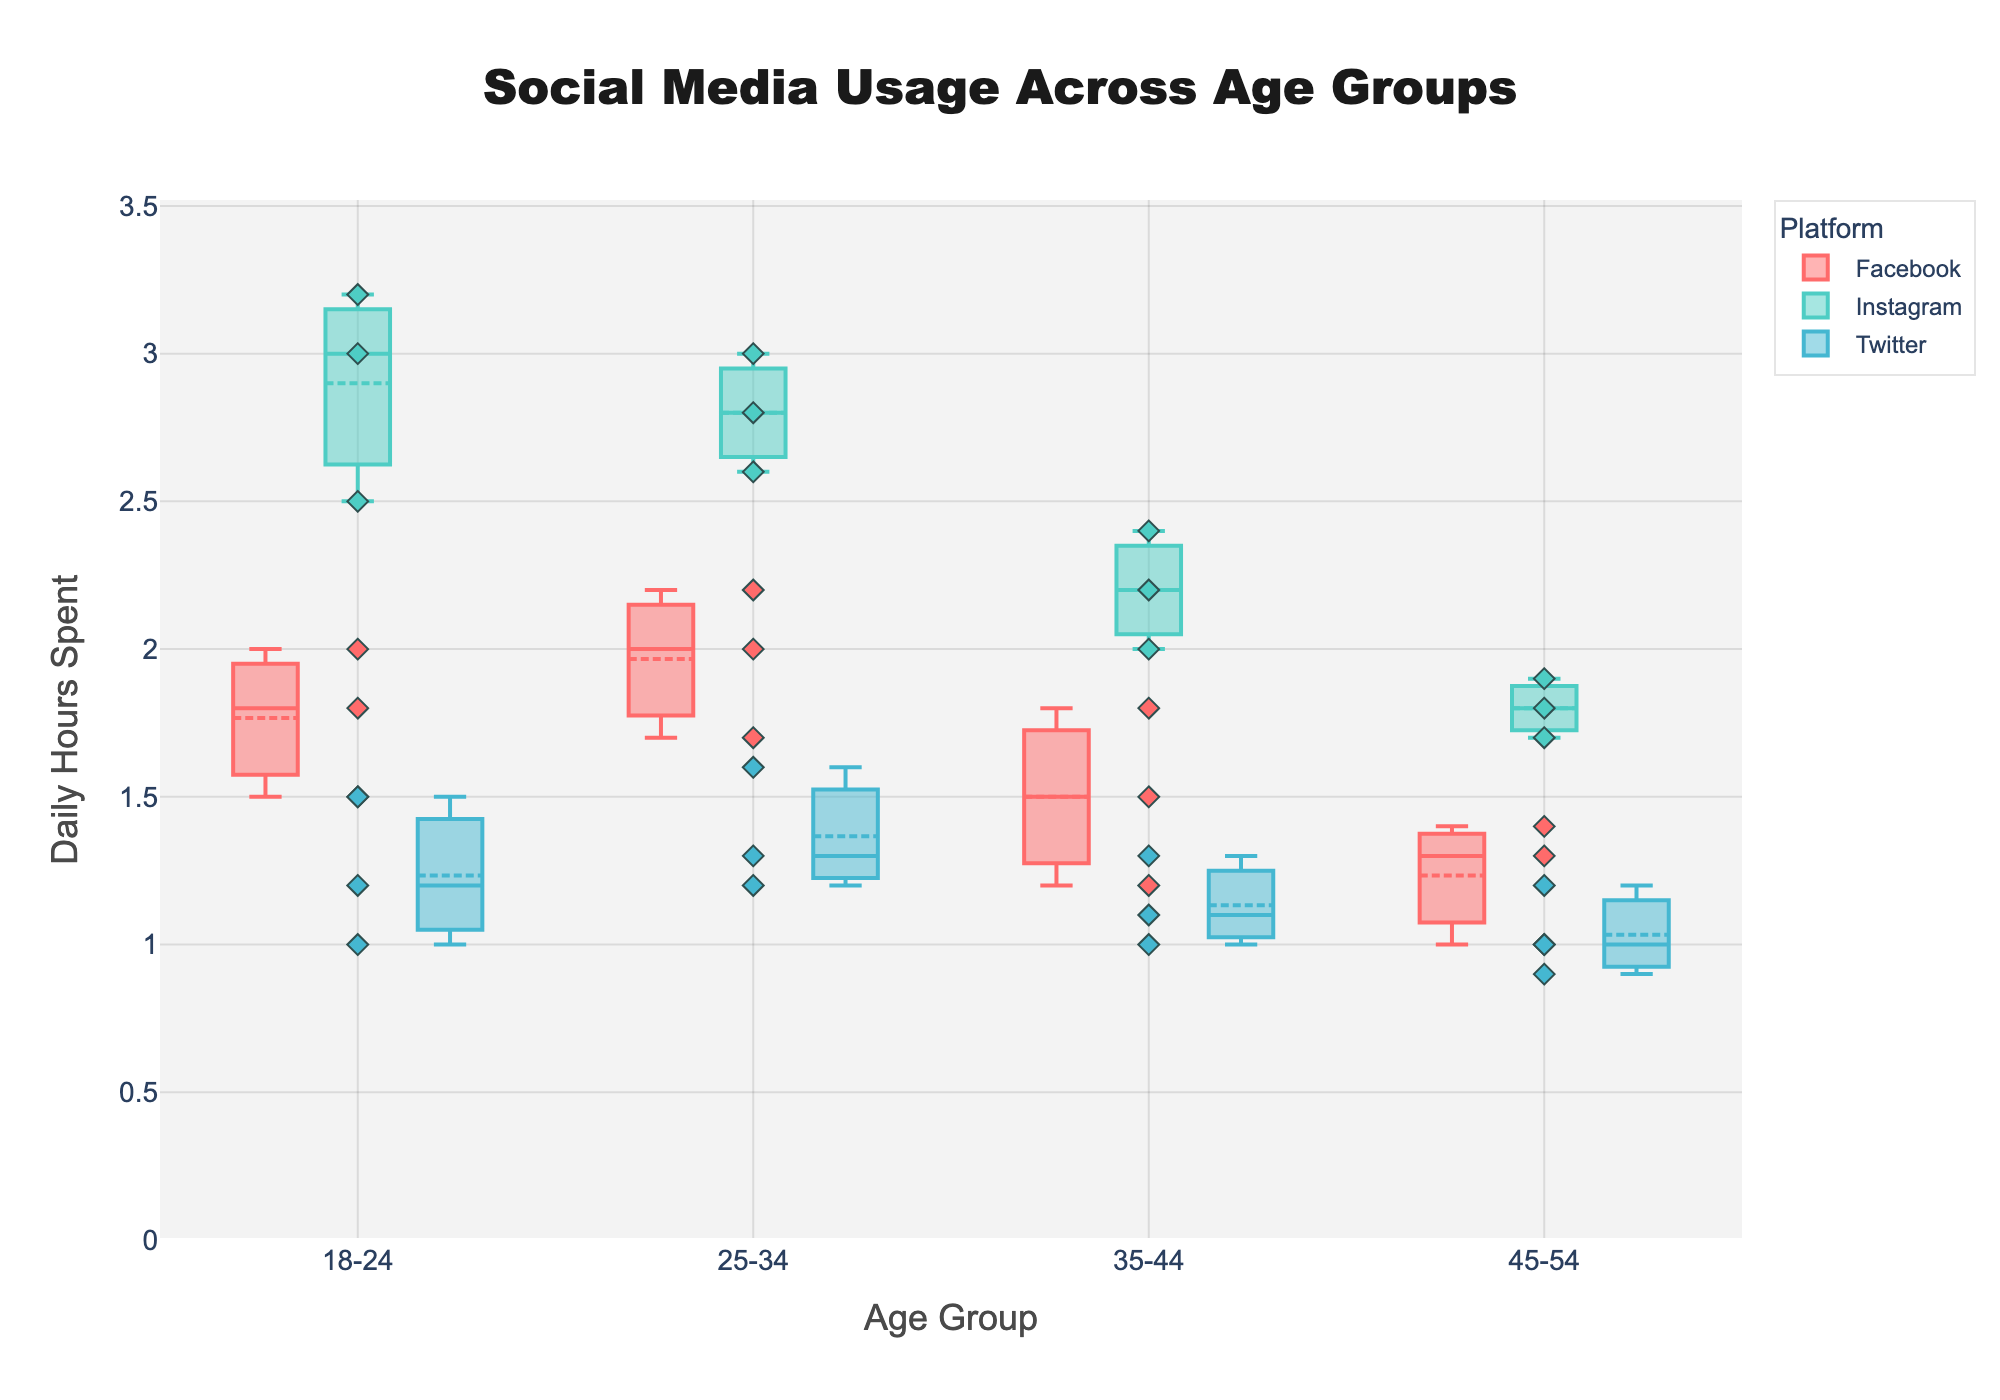Which age group spends the most time on Instagram on average? To determine the average time spent on Instagram by each age group, observe the median lines in the box plots for each group. The age group 18-24 has the highest median line for Instagram.
Answer: 18-24 How do the median daily hours compare between Facebook and Twitter for the 25-34 age group? Check the median lines in the box plots representing Facebook and Twitter under the 25-34 age category. Facebook's median is higher than Twitter's.
Answer: Facebook has higher median daily hours What is the range of daily hours spent on Facebook by the 35-44 age group? To find the range, look at the minimum and maximum "whiskers" of the box plot for Facebook in the 35-44 age group. The minimum is 1.2 and the maximum is 1.8 hours. Thus, the range is 1.8 - 1.2.
Answer: 0.6 hours Which platform shows the most variation in daily hours among the 45-54 age group? Variation is indicated by the length of the box. For the 45-54 age group, compare the length of the boxes for Facebook, Instagram, and Twitter. Facebook shows the most variation.
Answer: Facebook What is the median daily hours spent on social media by the 18-24 age group across all platforms? Calculate the median of the combined daily hours for all platforms in the 18-24 age group by visually estimating the center of each box plot and looking at where most points cluster. Median lines suggest around 1.8 for Facebook, 2.5 for Instagram, and 1.2 for Twitter. The median is about 2.0 hours.
Answer: 2.0 hours Among the 35-44 age group, which platform has the smallest interquartile range (IQR) of daily hours? The IQR is represented by the length of the box, spanning from Q1 to Q3. For the 35-44 age group, compare the boxes. Twitter has the smallest IQR.
Answer: Twitter How does the maximum reported daily hours vary between age groups for Instagram? Evaluate the upper whiskers for Instagram across all age groups. 18-24 has the highest maximum at 3.2 hours, followed by 25-34 at 3.0 hours, 35-44 at 2.4 hours, and 45-54 at 1.9 hours.
Answer: Decreases with age What is the lowest daily hour value recorded for Twitter users in the 18-24 age group? Check the bottom whisker of the Twitter box plot for 18-24. The lowest value is 1.0 hours.
Answer: 1.0 hours Which platform has the highest individual data point in terms of daily hours for the 25-34 age group? Look for the highest scatter points above the box plots for each platform in the 25-34 age group. Instagram has the highest with a data point at 3.0 hours.
Answer: Instagram 